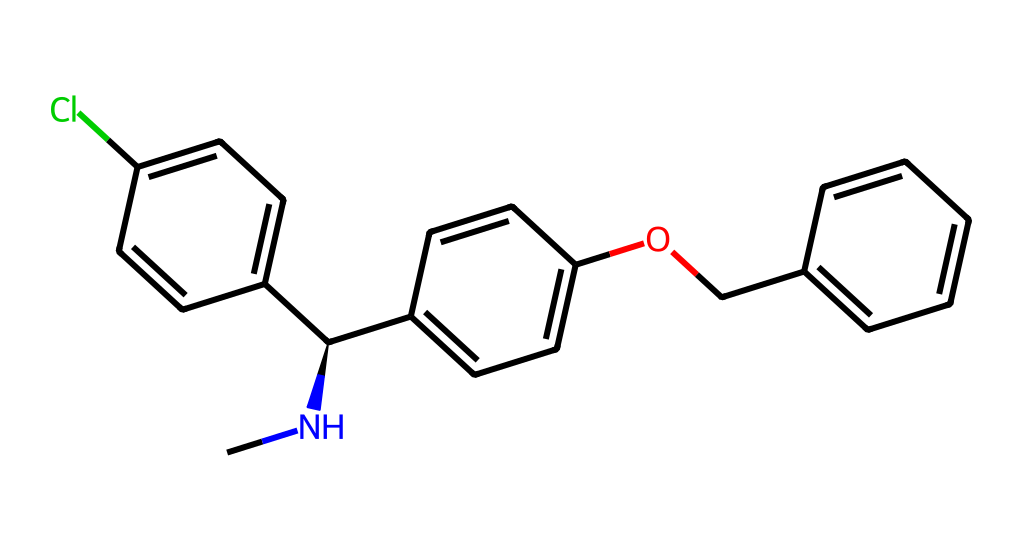How many carbon atoms are in the structure? The SMILES representation contains several 'C' notations. Counting them gives a total of 17 carbon atoms in the entire structure.
Answer: 17 What functional group is indicated by the presence of -OCC-? The presence of -OCC- indicates an ether group due to the ether linkage where an oxygen atom is connected between two carbon chains. This can be identified in the structure when examining the connectivity of atoms.
Answer: ether How many rings are present in the chemical structure? The chemical structure includes two distinct benzene rings (which are hexagonal, aromatic structures). By examining the cyclic nature of the structure, it's confirmed to have two rings total.
Answer: 2 What is the stereochemistry at the chiral center? The structure contains a chiral center at the nitrogen atom (noted by 'C@H'). The '@' symbol indicates that the chiral center has specific stereochemistry, which is typically designated as 'R' or 'S'. This particular representation suggests an 'R' configuration due to its placement in 3D space, but without visual representation, one cannot definitively assign it.
Answer: R Which halogen is present in the structure? The presence of 'Cl' in the SMILES indicates chlorine is the halogen. This can be directly observed in the written structure without ambiguity, as it directly appears in the molecular notation.
Answer: chlorine 